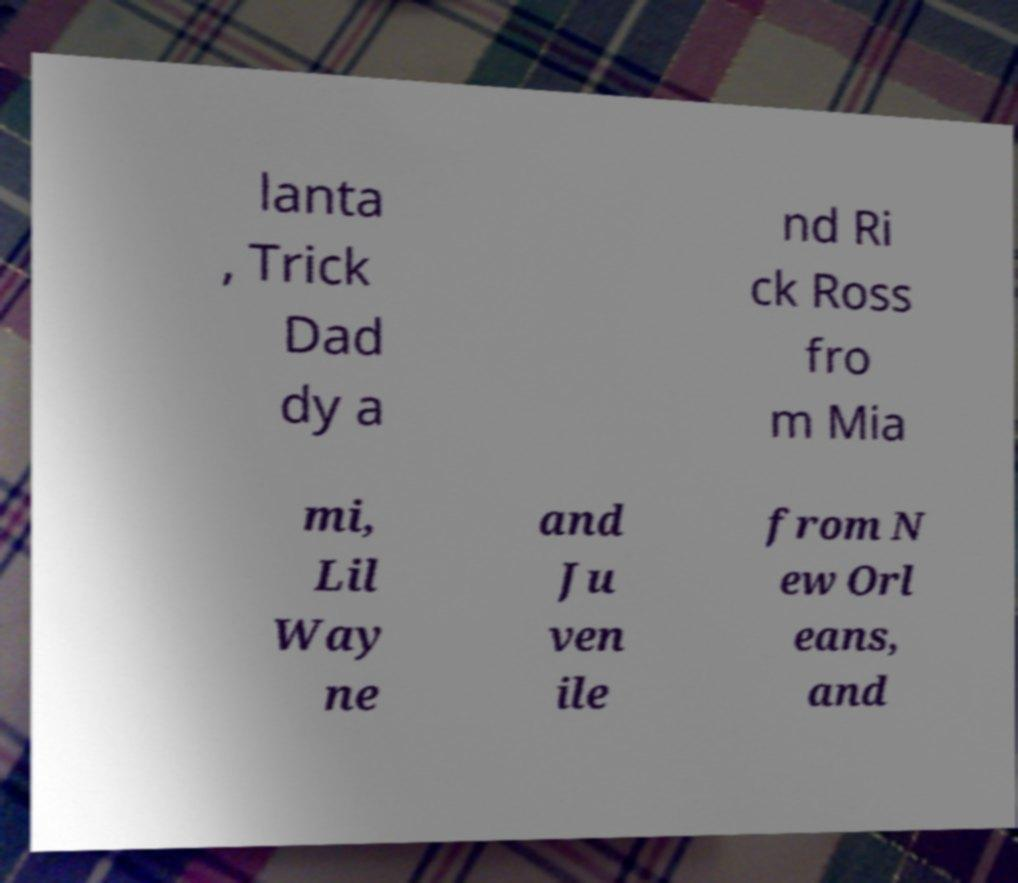Please identify and transcribe the text found in this image. lanta , Trick Dad dy a nd Ri ck Ross fro m Mia mi, Lil Way ne and Ju ven ile from N ew Orl eans, and 